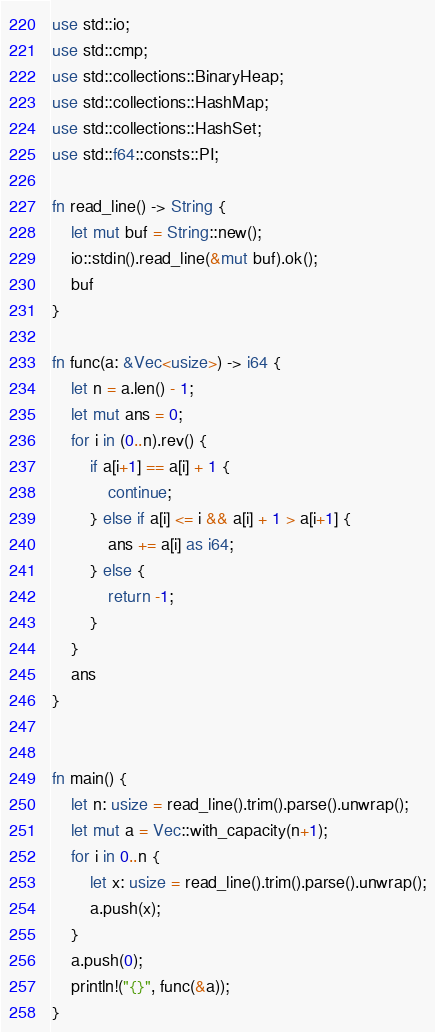Convert code to text. <code><loc_0><loc_0><loc_500><loc_500><_Rust_>use std::io;
use std::cmp;
use std::collections::BinaryHeap;
use std::collections::HashMap;
use std::collections::HashSet;
use std::f64::consts::PI;

fn read_line() -> String {
    let mut buf = String::new();
    io::stdin().read_line(&mut buf).ok();
    buf
}

fn func(a: &Vec<usize>) -> i64 {
    let n = a.len() - 1;
    let mut ans = 0;
    for i in (0..n).rev() {
        if a[i+1] == a[i] + 1 {
            continue;
        } else if a[i] <= i && a[i] + 1 > a[i+1] {
            ans += a[i] as i64;
        } else {
            return -1;
        }
    }
    ans
}


fn main() {
    let n: usize = read_line().trim().parse().unwrap();
    let mut a = Vec::with_capacity(n+1);
    for i in 0..n {
        let x: usize = read_line().trim().parse().unwrap();
        a.push(x);
    }
    a.push(0);
    println!("{}", func(&a));
}
</code> 